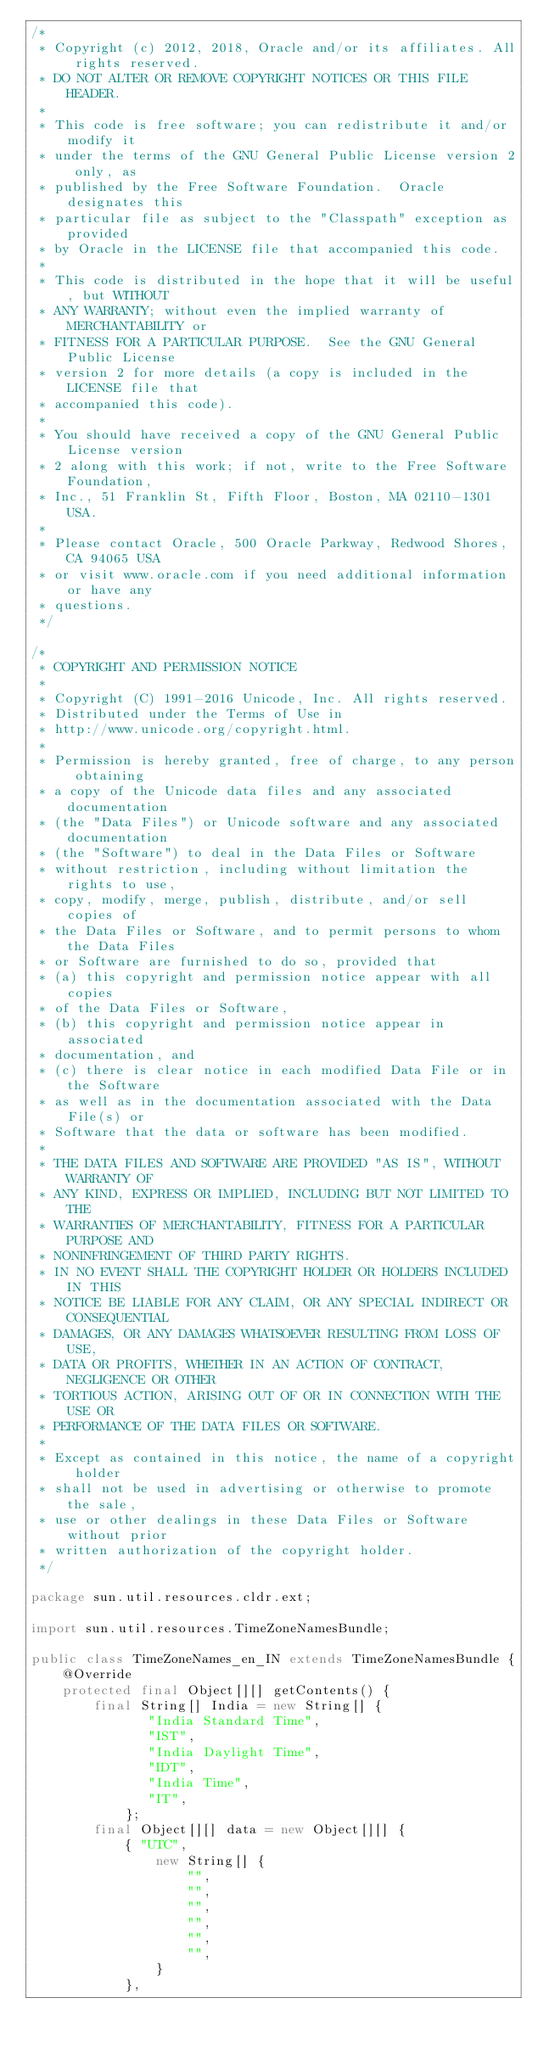<code> <loc_0><loc_0><loc_500><loc_500><_Java_>/*
 * Copyright (c) 2012, 2018, Oracle and/or its affiliates. All rights reserved.
 * DO NOT ALTER OR REMOVE COPYRIGHT NOTICES OR THIS FILE HEADER.
 *
 * This code is free software; you can redistribute it and/or modify it
 * under the terms of the GNU General Public License version 2 only, as
 * published by the Free Software Foundation.  Oracle designates this
 * particular file as subject to the "Classpath" exception as provided
 * by Oracle in the LICENSE file that accompanied this code.
 *
 * This code is distributed in the hope that it will be useful, but WITHOUT
 * ANY WARRANTY; without even the implied warranty of MERCHANTABILITY or
 * FITNESS FOR A PARTICULAR PURPOSE.  See the GNU General Public License
 * version 2 for more details (a copy is included in the LICENSE file that
 * accompanied this code).
 *
 * You should have received a copy of the GNU General Public License version
 * 2 along with this work; if not, write to the Free Software Foundation,
 * Inc., 51 Franklin St, Fifth Floor, Boston, MA 02110-1301 USA.
 *
 * Please contact Oracle, 500 Oracle Parkway, Redwood Shores, CA 94065 USA
 * or visit www.oracle.com if you need additional information or have any
 * questions.
 */

/*
 * COPYRIGHT AND PERMISSION NOTICE
 *
 * Copyright (C) 1991-2016 Unicode, Inc. All rights reserved.
 * Distributed under the Terms of Use in 
 * http://www.unicode.org/copyright.html.
 *
 * Permission is hereby granted, free of charge, to any person obtaining
 * a copy of the Unicode data files and any associated documentation
 * (the "Data Files") or Unicode software and any associated documentation
 * (the "Software") to deal in the Data Files or Software
 * without restriction, including without limitation the rights to use,
 * copy, modify, merge, publish, distribute, and/or sell copies of
 * the Data Files or Software, and to permit persons to whom the Data Files
 * or Software are furnished to do so, provided that
 * (a) this copyright and permission notice appear with all copies 
 * of the Data Files or Software,
 * (b) this copyright and permission notice appear in associated 
 * documentation, and
 * (c) there is clear notice in each modified Data File or in the Software
 * as well as in the documentation associated with the Data File(s) or
 * Software that the data or software has been modified.
 *
 * THE DATA FILES AND SOFTWARE ARE PROVIDED "AS IS", WITHOUT WARRANTY OF
 * ANY KIND, EXPRESS OR IMPLIED, INCLUDING BUT NOT LIMITED TO THE
 * WARRANTIES OF MERCHANTABILITY, FITNESS FOR A PARTICULAR PURPOSE AND
 * NONINFRINGEMENT OF THIRD PARTY RIGHTS.
 * IN NO EVENT SHALL THE COPYRIGHT HOLDER OR HOLDERS INCLUDED IN THIS
 * NOTICE BE LIABLE FOR ANY CLAIM, OR ANY SPECIAL INDIRECT OR CONSEQUENTIAL
 * DAMAGES, OR ANY DAMAGES WHATSOEVER RESULTING FROM LOSS OF USE,
 * DATA OR PROFITS, WHETHER IN AN ACTION OF CONTRACT, NEGLIGENCE OR OTHER
 * TORTIOUS ACTION, ARISING OUT OF OR IN CONNECTION WITH THE USE OR
 * PERFORMANCE OF THE DATA FILES OR SOFTWARE.
 *
 * Except as contained in this notice, the name of a copyright holder
 * shall not be used in advertising or otherwise to promote the sale,
 * use or other dealings in these Data Files or Software without prior
 * written authorization of the copyright holder.
 */

package sun.util.resources.cldr.ext;

import sun.util.resources.TimeZoneNamesBundle;

public class TimeZoneNames_en_IN extends TimeZoneNamesBundle {
    @Override
    protected final Object[][] getContents() {
        final String[] India = new String[] {
               "India Standard Time",
               "IST",
               "India Daylight Time",
               "IDT",
               "India Time",
               "IT",
            };
        final Object[][] data = new Object[][] {
            { "UTC",
                new String[] {
                    "",
                    "",
                    "",
                    "",
                    "",
                    "",
                }
            },</code> 